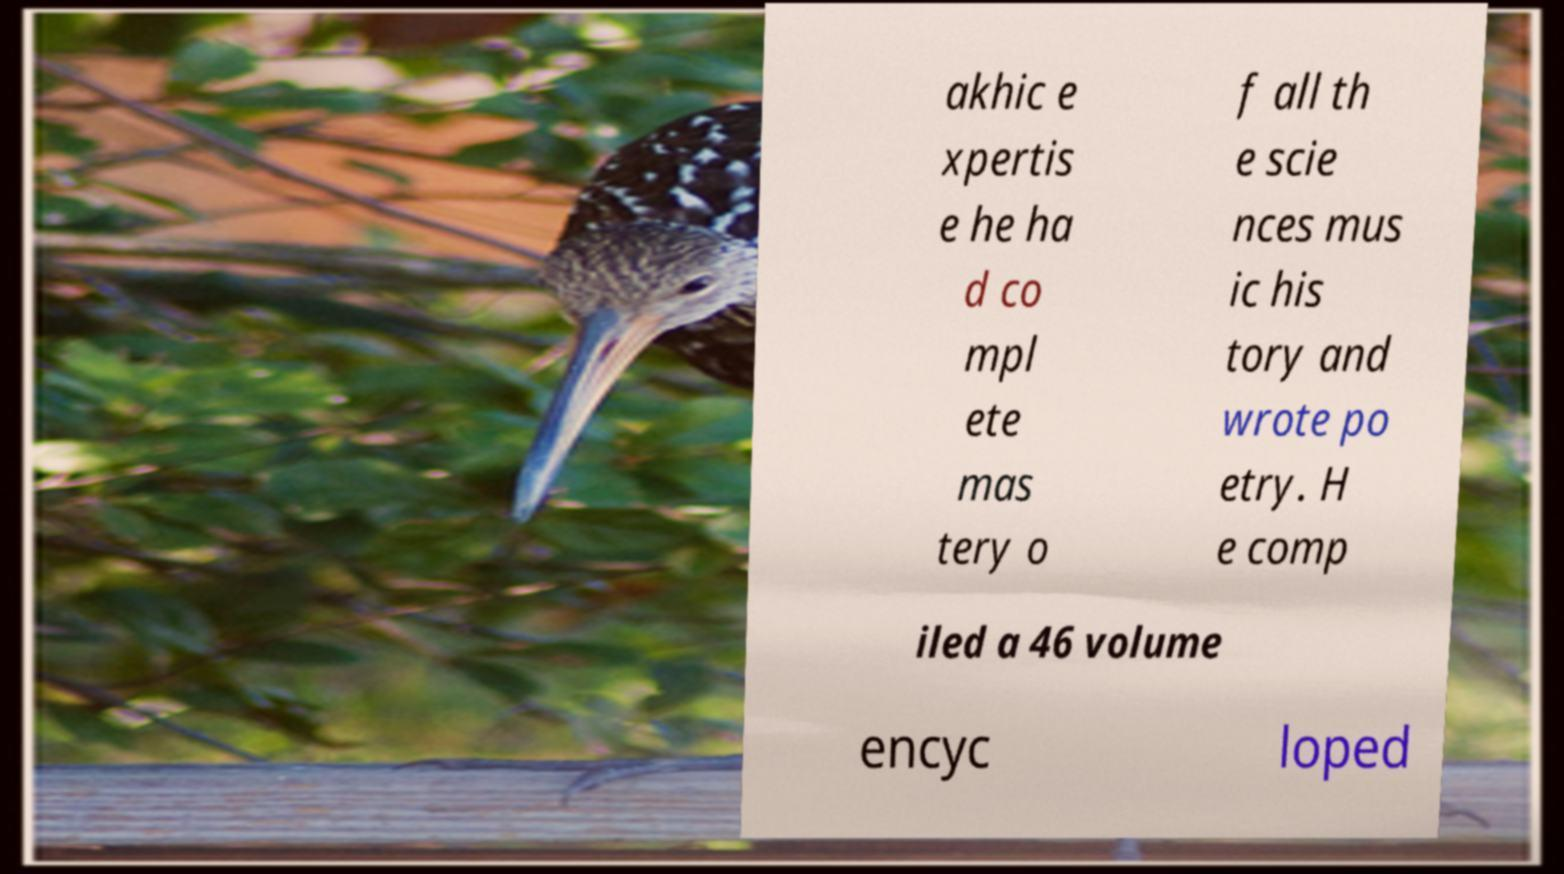For documentation purposes, I need the text within this image transcribed. Could you provide that? akhic e xpertis e he ha d co mpl ete mas tery o f all th e scie nces mus ic his tory and wrote po etry. H e comp iled a 46 volume encyc loped 